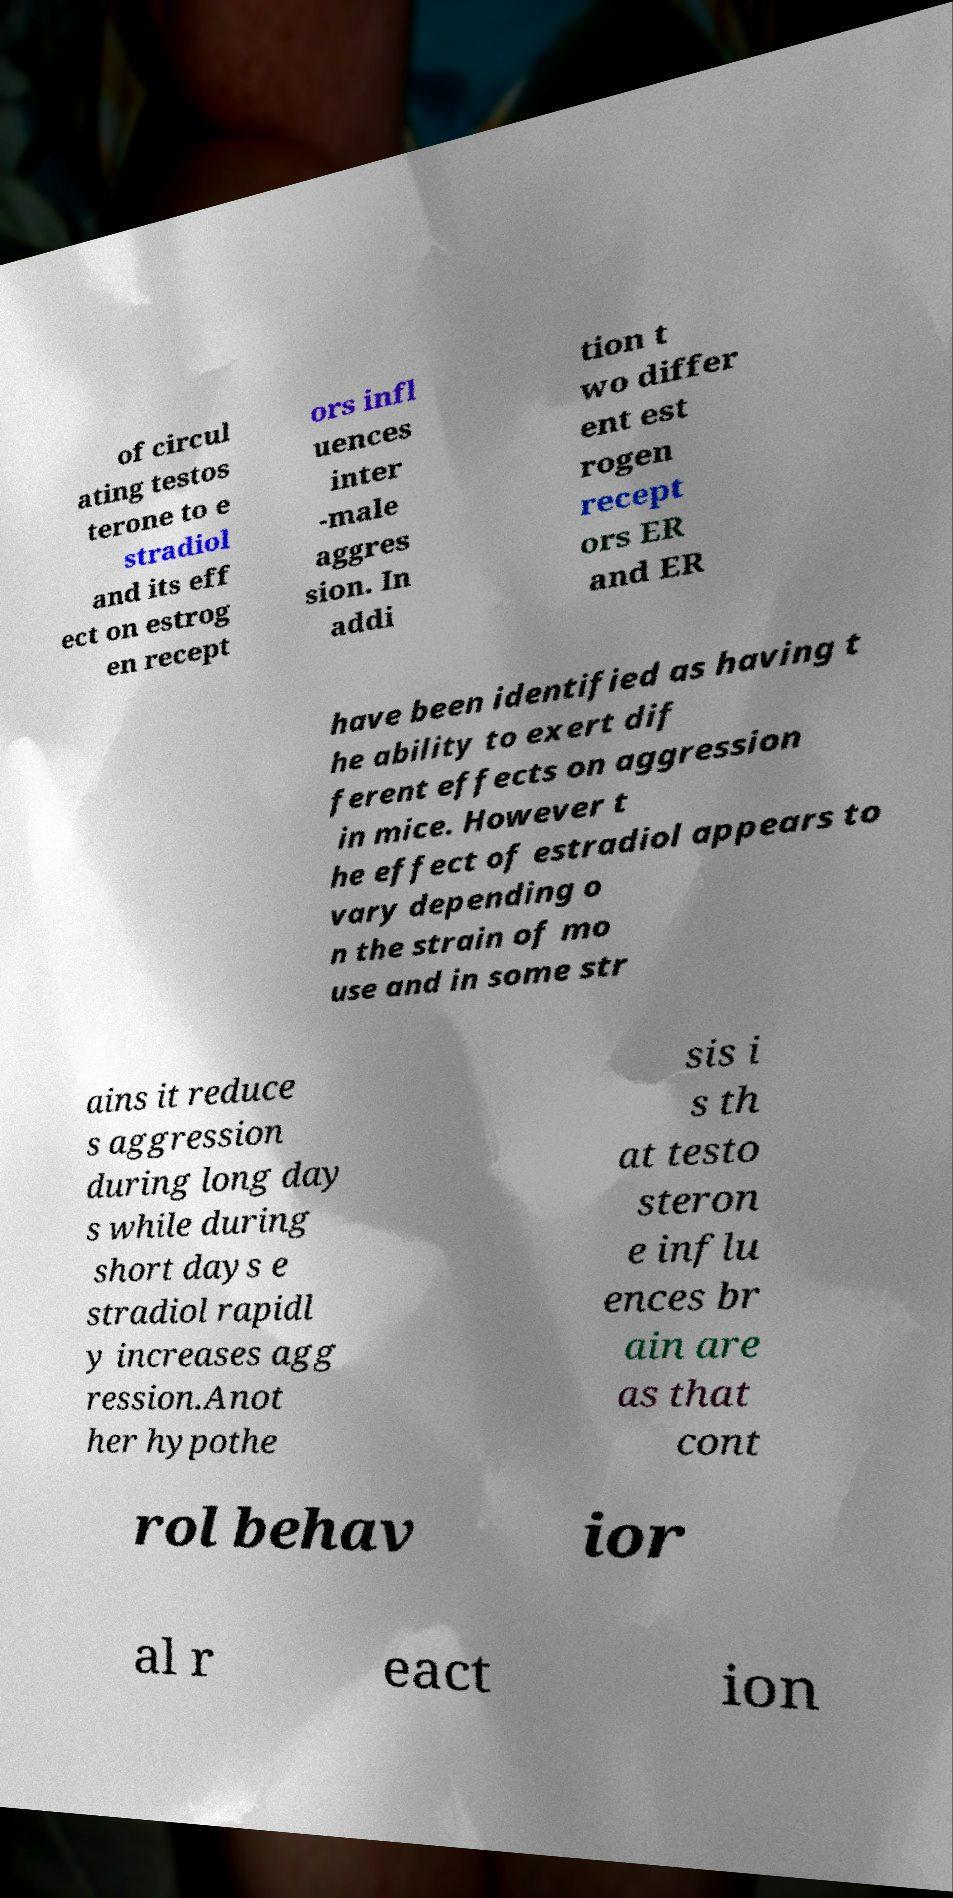Could you assist in decoding the text presented in this image and type it out clearly? of circul ating testos terone to e stradiol and its eff ect on estrog en recept ors infl uences inter -male aggres sion. In addi tion t wo differ ent est rogen recept ors ER and ER have been identified as having t he ability to exert dif ferent effects on aggression in mice. However t he effect of estradiol appears to vary depending o n the strain of mo use and in some str ains it reduce s aggression during long day s while during short days e stradiol rapidl y increases agg ression.Anot her hypothe sis i s th at testo steron e influ ences br ain are as that cont rol behav ior al r eact ion 